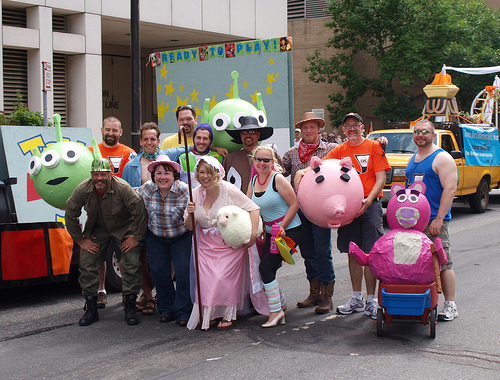<image>
Can you confirm if the old lady is behind the man? No. The old lady is not behind the man. From this viewpoint, the old lady appears to be positioned elsewhere in the scene. Where is the man in relation to the alien? Is it in front of the alien? No. The man is not in front of the alien. The spatial positioning shows a different relationship between these objects. 